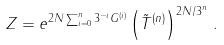Convert formula to latex. <formula><loc_0><loc_0><loc_500><loc_500>Z = e ^ { 2 N \sum _ { i = 0 } ^ { n } 3 ^ { - i } G ^ { ( i ) } } \left ( \tilde { T } ^ { ( n ) } \right ) ^ { 2 N / 3 ^ { n } } \, .</formula> 